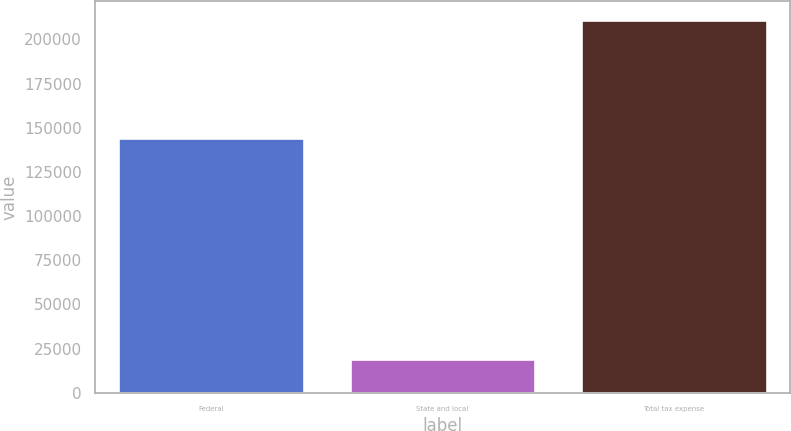Convert chart to OTSL. <chart><loc_0><loc_0><loc_500><loc_500><bar_chart><fcel>Federal<fcel>State and local<fcel>Total tax expense<nl><fcel>144299<fcel>18811<fcel>211186<nl></chart> 